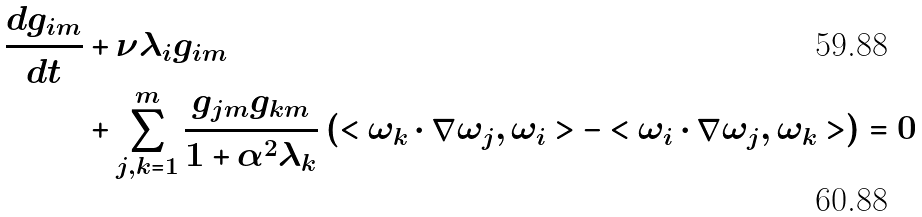Convert formula to latex. <formula><loc_0><loc_0><loc_500><loc_500>\frac { d g _ { i m } } { d t } & + \nu \lambda _ { i } g _ { i m } \\ & + \sum _ { j , k = 1 } ^ { m } \frac { g _ { j m } g _ { k m } } { 1 + \alpha ^ { 2 } \lambda _ { k } } \left ( < \omega _ { k } \cdot \nabla \omega _ { j } , \omega _ { i } > - < \omega _ { i } \cdot \nabla \omega _ { j } , \omega _ { k } > \right ) = 0</formula> 